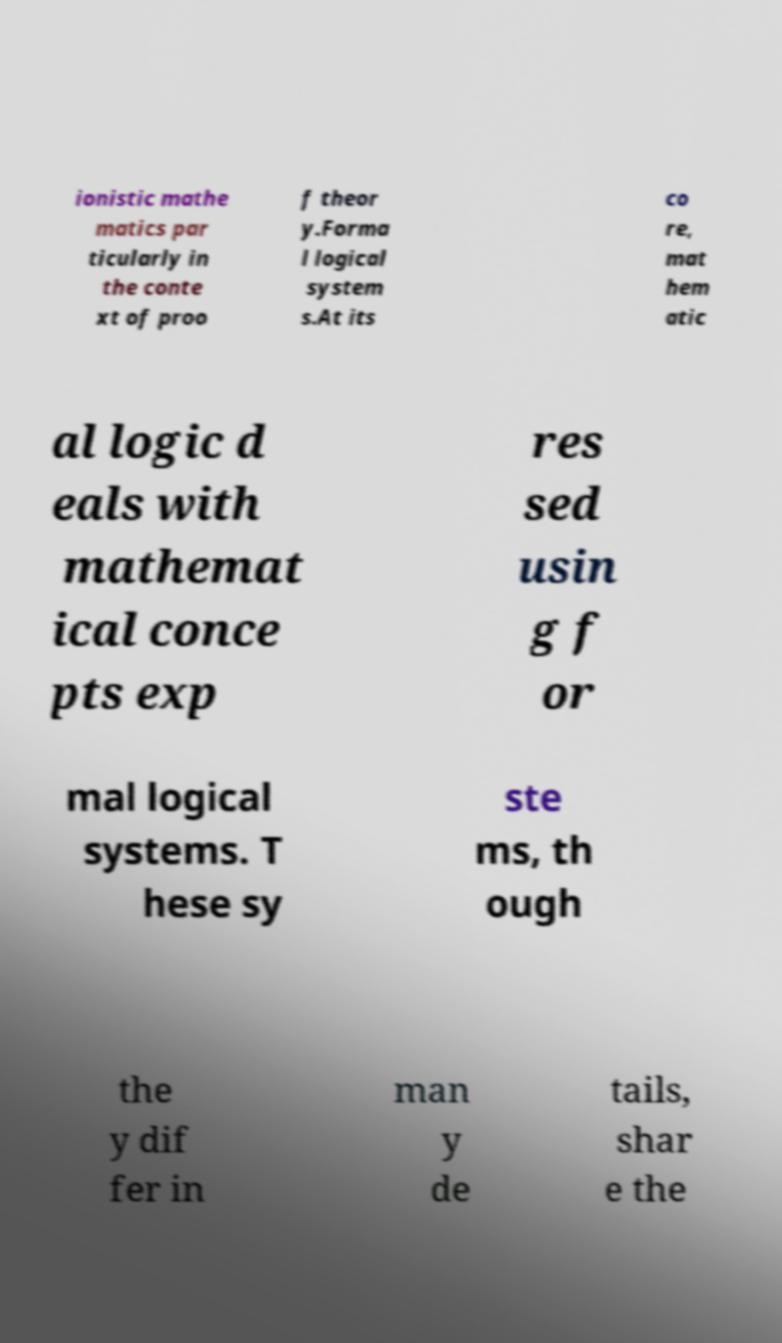Could you assist in decoding the text presented in this image and type it out clearly? ionistic mathe matics par ticularly in the conte xt of proo f theor y.Forma l logical system s.At its co re, mat hem atic al logic d eals with mathemat ical conce pts exp res sed usin g f or mal logical systems. T hese sy ste ms, th ough the y dif fer in man y de tails, shar e the 